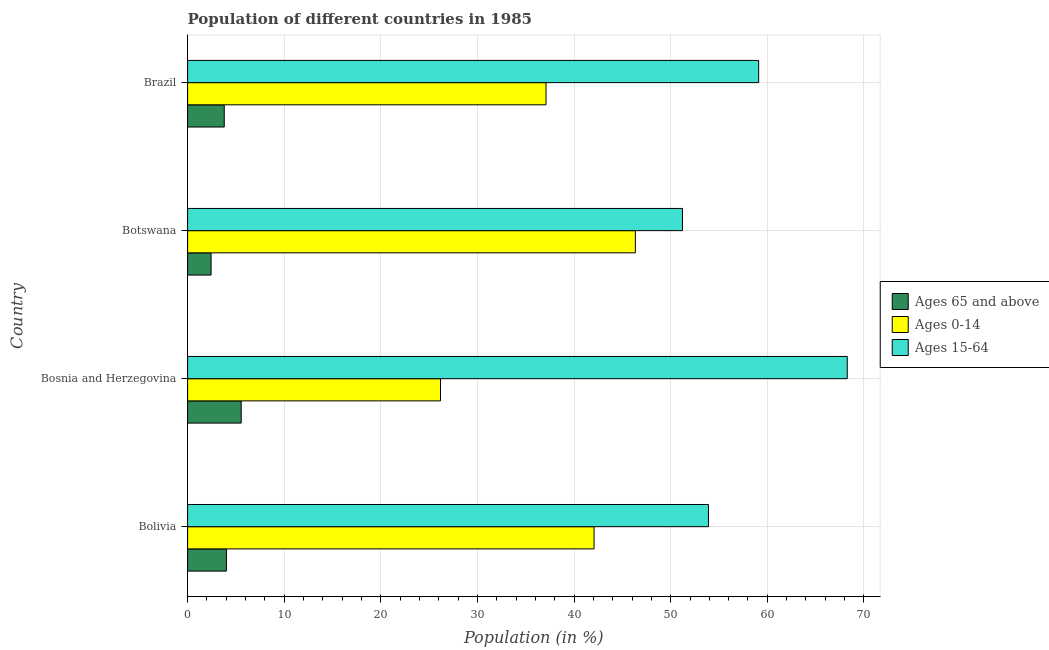How many different coloured bars are there?
Provide a succinct answer. 3. Are the number of bars on each tick of the Y-axis equal?
Offer a very short reply. Yes. How many bars are there on the 3rd tick from the top?
Provide a short and direct response. 3. What is the label of the 2nd group of bars from the top?
Offer a terse response. Botswana. In how many cases, is the number of bars for a given country not equal to the number of legend labels?
Make the answer very short. 0. What is the percentage of population within the age-group 15-64 in Bosnia and Herzegovina?
Offer a very short reply. 68.28. Across all countries, what is the maximum percentage of population within the age-group of 65 and above?
Your answer should be very brief. 5.55. Across all countries, what is the minimum percentage of population within the age-group of 65 and above?
Your answer should be very brief. 2.43. In which country was the percentage of population within the age-group of 65 and above maximum?
Offer a very short reply. Bosnia and Herzegovina. In which country was the percentage of population within the age-group 15-64 minimum?
Offer a very short reply. Botswana. What is the total percentage of population within the age-group of 65 and above in the graph?
Your answer should be compact. 15.79. What is the difference between the percentage of population within the age-group 0-14 in Bosnia and Herzegovina and that in Brazil?
Make the answer very short. -10.92. What is the difference between the percentage of population within the age-group of 65 and above in Bosnia and Herzegovina and the percentage of population within the age-group 15-64 in Bolivia?
Your answer should be very brief. -48.36. What is the average percentage of population within the age-group 15-64 per country?
Your response must be concise. 58.13. What is the difference between the percentage of population within the age-group 15-64 and percentage of population within the age-group of 65 and above in Bolivia?
Offer a terse response. 49.89. What is the ratio of the percentage of population within the age-group 15-64 in Bolivia to that in Bosnia and Herzegovina?
Your response must be concise. 0.79. Is the percentage of population within the age-group 15-64 in Bolivia less than that in Brazil?
Provide a short and direct response. Yes. What is the difference between the highest and the second highest percentage of population within the age-group 15-64?
Offer a terse response. 9.17. What is the difference between the highest and the lowest percentage of population within the age-group 15-64?
Your answer should be compact. 17.05. What does the 3rd bar from the top in Brazil represents?
Your answer should be compact. Ages 65 and above. What does the 1st bar from the bottom in Brazil represents?
Your response must be concise. Ages 65 and above. Is it the case that in every country, the sum of the percentage of population within the age-group of 65 and above and percentage of population within the age-group 0-14 is greater than the percentage of population within the age-group 15-64?
Provide a succinct answer. No. Are all the bars in the graph horizontal?
Provide a short and direct response. Yes. How many countries are there in the graph?
Give a very brief answer. 4. What is the title of the graph?
Your answer should be very brief. Population of different countries in 1985. What is the label or title of the X-axis?
Offer a terse response. Population (in %). What is the Population (in %) in Ages 65 and above in Bolivia?
Keep it short and to the point. 4.02. What is the Population (in %) in Ages 0-14 in Bolivia?
Your answer should be compact. 42.07. What is the Population (in %) of Ages 15-64 in Bolivia?
Ensure brevity in your answer.  53.91. What is the Population (in %) of Ages 65 and above in Bosnia and Herzegovina?
Keep it short and to the point. 5.55. What is the Population (in %) in Ages 0-14 in Bosnia and Herzegovina?
Provide a succinct answer. 26.18. What is the Population (in %) of Ages 15-64 in Bosnia and Herzegovina?
Provide a succinct answer. 68.28. What is the Population (in %) of Ages 65 and above in Botswana?
Your answer should be compact. 2.43. What is the Population (in %) of Ages 0-14 in Botswana?
Provide a succinct answer. 46.35. What is the Population (in %) of Ages 15-64 in Botswana?
Offer a very short reply. 51.22. What is the Population (in %) of Ages 65 and above in Brazil?
Give a very brief answer. 3.79. What is the Population (in %) in Ages 0-14 in Brazil?
Ensure brevity in your answer.  37.1. What is the Population (in %) in Ages 15-64 in Brazil?
Your answer should be compact. 59.11. Across all countries, what is the maximum Population (in %) in Ages 65 and above?
Keep it short and to the point. 5.55. Across all countries, what is the maximum Population (in %) in Ages 0-14?
Provide a succinct answer. 46.35. Across all countries, what is the maximum Population (in %) of Ages 15-64?
Offer a terse response. 68.28. Across all countries, what is the minimum Population (in %) in Ages 65 and above?
Provide a succinct answer. 2.43. Across all countries, what is the minimum Population (in %) in Ages 0-14?
Offer a terse response. 26.18. Across all countries, what is the minimum Population (in %) of Ages 15-64?
Keep it short and to the point. 51.22. What is the total Population (in %) in Ages 65 and above in the graph?
Make the answer very short. 15.79. What is the total Population (in %) in Ages 0-14 in the graph?
Provide a short and direct response. 151.69. What is the total Population (in %) of Ages 15-64 in the graph?
Keep it short and to the point. 232.51. What is the difference between the Population (in %) in Ages 65 and above in Bolivia and that in Bosnia and Herzegovina?
Your response must be concise. -1.53. What is the difference between the Population (in %) in Ages 0-14 in Bolivia and that in Bosnia and Herzegovina?
Give a very brief answer. 15.89. What is the difference between the Population (in %) in Ages 15-64 in Bolivia and that in Bosnia and Herzegovina?
Make the answer very short. -14.37. What is the difference between the Population (in %) in Ages 65 and above in Bolivia and that in Botswana?
Give a very brief answer. 1.59. What is the difference between the Population (in %) in Ages 0-14 in Bolivia and that in Botswana?
Ensure brevity in your answer.  -4.28. What is the difference between the Population (in %) in Ages 15-64 in Bolivia and that in Botswana?
Make the answer very short. 2.69. What is the difference between the Population (in %) of Ages 65 and above in Bolivia and that in Brazil?
Offer a terse response. 0.23. What is the difference between the Population (in %) of Ages 0-14 in Bolivia and that in Brazil?
Offer a terse response. 4.97. What is the difference between the Population (in %) of Ages 15-64 in Bolivia and that in Brazil?
Make the answer very short. -5.2. What is the difference between the Population (in %) of Ages 65 and above in Bosnia and Herzegovina and that in Botswana?
Provide a short and direct response. 3.12. What is the difference between the Population (in %) in Ages 0-14 in Bosnia and Herzegovina and that in Botswana?
Your answer should be very brief. -20.17. What is the difference between the Population (in %) of Ages 15-64 in Bosnia and Herzegovina and that in Botswana?
Ensure brevity in your answer.  17.05. What is the difference between the Population (in %) in Ages 65 and above in Bosnia and Herzegovina and that in Brazil?
Keep it short and to the point. 1.75. What is the difference between the Population (in %) in Ages 0-14 in Bosnia and Herzegovina and that in Brazil?
Provide a succinct answer. -10.92. What is the difference between the Population (in %) in Ages 15-64 in Bosnia and Herzegovina and that in Brazil?
Offer a very short reply. 9.17. What is the difference between the Population (in %) of Ages 65 and above in Botswana and that in Brazil?
Your answer should be compact. -1.36. What is the difference between the Population (in %) in Ages 0-14 in Botswana and that in Brazil?
Make the answer very short. 9.25. What is the difference between the Population (in %) in Ages 15-64 in Botswana and that in Brazil?
Your response must be concise. -7.88. What is the difference between the Population (in %) in Ages 65 and above in Bolivia and the Population (in %) in Ages 0-14 in Bosnia and Herzegovina?
Give a very brief answer. -22.16. What is the difference between the Population (in %) in Ages 65 and above in Bolivia and the Population (in %) in Ages 15-64 in Bosnia and Herzegovina?
Your response must be concise. -64.26. What is the difference between the Population (in %) in Ages 0-14 in Bolivia and the Population (in %) in Ages 15-64 in Bosnia and Herzegovina?
Keep it short and to the point. -26.2. What is the difference between the Population (in %) of Ages 65 and above in Bolivia and the Population (in %) of Ages 0-14 in Botswana?
Make the answer very short. -42.33. What is the difference between the Population (in %) of Ages 65 and above in Bolivia and the Population (in %) of Ages 15-64 in Botswana?
Ensure brevity in your answer.  -47.2. What is the difference between the Population (in %) of Ages 0-14 in Bolivia and the Population (in %) of Ages 15-64 in Botswana?
Your answer should be compact. -9.15. What is the difference between the Population (in %) in Ages 65 and above in Bolivia and the Population (in %) in Ages 0-14 in Brazil?
Offer a very short reply. -33.08. What is the difference between the Population (in %) in Ages 65 and above in Bolivia and the Population (in %) in Ages 15-64 in Brazil?
Make the answer very short. -55.09. What is the difference between the Population (in %) in Ages 0-14 in Bolivia and the Population (in %) in Ages 15-64 in Brazil?
Keep it short and to the point. -17.04. What is the difference between the Population (in %) of Ages 65 and above in Bosnia and Herzegovina and the Population (in %) of Ages 0-14 in Botswana?
Keep it short and to the point. -40.8. What is the difference between the Population (in %) in Ages 65 and above in Bosnia and Herzegovina and the Population (in %) in Ages 15-64 in Botswana?
Offer a terse response. -45.67. What is the difference between the Population (in %) in Ages 0-14 in Bosnia and Herzegovina and the Population (in %) in Ages 15-64 in Botswana?
Offer a very short reply. -25.05. What is the difference between the Population (in %) in Ages 65 and above in Bosnia and Herzegovina and the Population (in %) in Ages 0-14 in Brazil?
Make the answer very short. -31.55. What is the difference between the Population (in %) in Ages 65 and above in Bosnia and Herzegovina and the Population (in %) in Ages 15-64 in Brazil?
Make the answer very short. -53.56. What is the difference between the Population (in %) of Ages 0-14 in Bosnia and Herzegovina and the Population (in %) of Ages 15-64 in Brazil?
Provide a short and direct response. -32.93. What is the difference between the Population (in %) of Ages 65 and above in Botswana and the Population (in %) of Ages 0-14 in Brazil?
Offer a very short reply. -34.67. What is the difference between the Population (in %) in Ages 65 and above in Botswana and the Population (in %) in Ages 15-64 in Brazil?
Your answer should be compact. -56.68. What is the difference between the Population (in %) in Ages 0-14 in Botswana and the Population (in %) in Ages 15-64 in Brazil?
Provide a succinct answer. -12.76. What is the average Population (in %) in Ages 65 and above per country?
Provide a succinct answer. 3.95. What is the average Population (in %) of Ages 0-14 per country?
Offer a terse response. 37.92. What is the average Population (in %) of Ages 15-64 per country?
Provide a succinct answer. 58.13. What is the difference between the Population (in %) in Ages 65 and above and Population (in %) in Ages 0-14 in Bolivia?
Your response must be concise. -38.05. What is the difference between the Population (in %) in Ages 65 and above and Population (in %) in Ages 15-64 in Bolivia?
Offer a very short reply. -49.89. What is the difference between the Population (in %) of Ages 0-14 and Population (in %) of Ages 15-64 in Bolivia?
Give a very brief answer. -11.84. What is the difference between the Population (in %) in Ages 65 and above and Population (in %) in Ages 0-14 in Bosnia and Herzegovina?
Ensure brevity in your answer.  -20.63. What is the difference between the Population (in %) in Ages 65 and above and Population (in %) in Ages 15-64 in Bosnia and Herzegovina?
Your answer should be very brief. -62.73. What is the difference between the Population (in %) in Ages 0-14 and Population (in %) in Ages 15-64 in Bosnia and Herzegovina?
Give a very brief answer. -42.1. What is the difference between the Population (in %) in Ages 65 and above and Population (in %) in Ages 0-14 in Botswana?
Ensure brevity in your answer.  -43.92. What is the difference between the Population (in %) in Ages 65 and above and Population (in %) in Ages 15-64 in Botswana?
Your answer should be very brief. -48.79. What is the difference between the Population (in %) of Ages 0-14 and Population (in %) of Ages 15-64 in Botswana?
Provide a short and direct response. -4.88. What is the difference between the Population (in %) of Ages 65 and above and Population (in %) of Ages 0-14 in Brazil?
Your response must be concise. -33.3. What is the difference between the Population (in %) of Ages 65 and above and Population (in %) of Ages 15-64 in Brazil?
Your answer should be very brief. -55.31. What is the difference between the Population (in %) in Ages 0-14 and Population (in %) in Ages 15-64 in Brazil?
Your answer should be compact. -22.01. What is the ratio of the Population (in %) in Ages 65 and above in Bolivia to that in Bosnia and Herzegovina?
Ensure brevity in your answer.  0.72. What is the ratio of the Population (in %) of Ages 0-14 in Bolivia to that in Bosnia and Herzegovina?
Make the answer very short. 1.61. What is the ratio of the Population (in %) in Ages 15-64 in Bolivia to that in Bosnia and Herzegovina?
Your response must be concise. 0.79. What is the ratio of the Population (in %) in Ages 65 and above in Bolivia to that in Botswana?
Offer a very short reply. 1.65. What is the ratio of the Population (in %) of Ages 0-14 in Bolivia to that in Botswana?
Give a very brief answer. 0.91. What is the ratio of the Population (in %) of Ages 15-64 in Bolivia to that in Botswana?
Offer a terse response. 1.05. What is the ratio of the Population (in %) of Ages 65 and above in Bolivia to that in Brazil?
Make the answer very short. 1.06. What is the ratio of the Population (in %) of Ages 0-14 in Bolivia to that in Brazil?
Your response must be concise. 1.13. What is the ratio of the Population (in %) of Ages 15-64 in Bolivia to that in Brazil?
Offer a very short reply. 0.91. What is the ratio of the Population (in %) in Ages 65 and above in Bosnia and Herzegovina to that in Botswana?
Offer a terse response. 2.28. What is the ratio of the Population (in %) of Ages 0-14 in Bosnia and Herzegovina to that in Botswana?
Your answer should be very brief. 0.56. What is the ratio of the Population (in %) in Ages 15-64 in Bosnia and Herzegovina to that in Botswana?
Provide a succinct answer. 1.33. What is the ratio of the Population (in %) of Ages 65 and above in Bosnia and Herzegovina to that in Brazil?
Your response must be concise. 1.46. What is the ratio of the Population (in %) of Ages 0-14 in Bosnia and Herzegovina to that in Brazil?
Your answer should be very brief. 0.71. What is the ratio of the Population (in %) of Ages 15-64 in Bosnia and Herzegovina to that in Brazil?
Provide a succinct answer. 1.16. What is the ratio of the Population (in %) of Ages 65 and above in Botswana to that in Brazil?
Offer a very short reply. 0.64. What is the ratio of the Population (in %) in Ages 0-14 in Botswana to that in Brazil?
Offer a very short reply. 1.25. What is the ratio of the Population (in %) of Ages 15-64 in Botswana to that in Brazil?
Make the answer very short. 0.87. What is the difference between the highest and the second highest Population (in %) of Ages 65 and above?
Provide a succinct answer. 1.53. What is the difference between the highest and the second highest Population (in %) in Ages 0-14?
Your answer should be compact. 4.28. What is the difference between the highest and the second highest Population (in %) of Ages 15-64?
Your response must be concise. 9.17. What is the difference between the highest and the lowest Population (in %) in Ages 65 and above?
Provide a short and direct response. 3.12. What is the difference between the highest and the lowest Population (in %) in Ages 0-14?
Your response must be concise. 20.17. What is the difference between the highest and the lowest Population (in %) in Ages 15-64?
Offer a terse response. 17.05. 